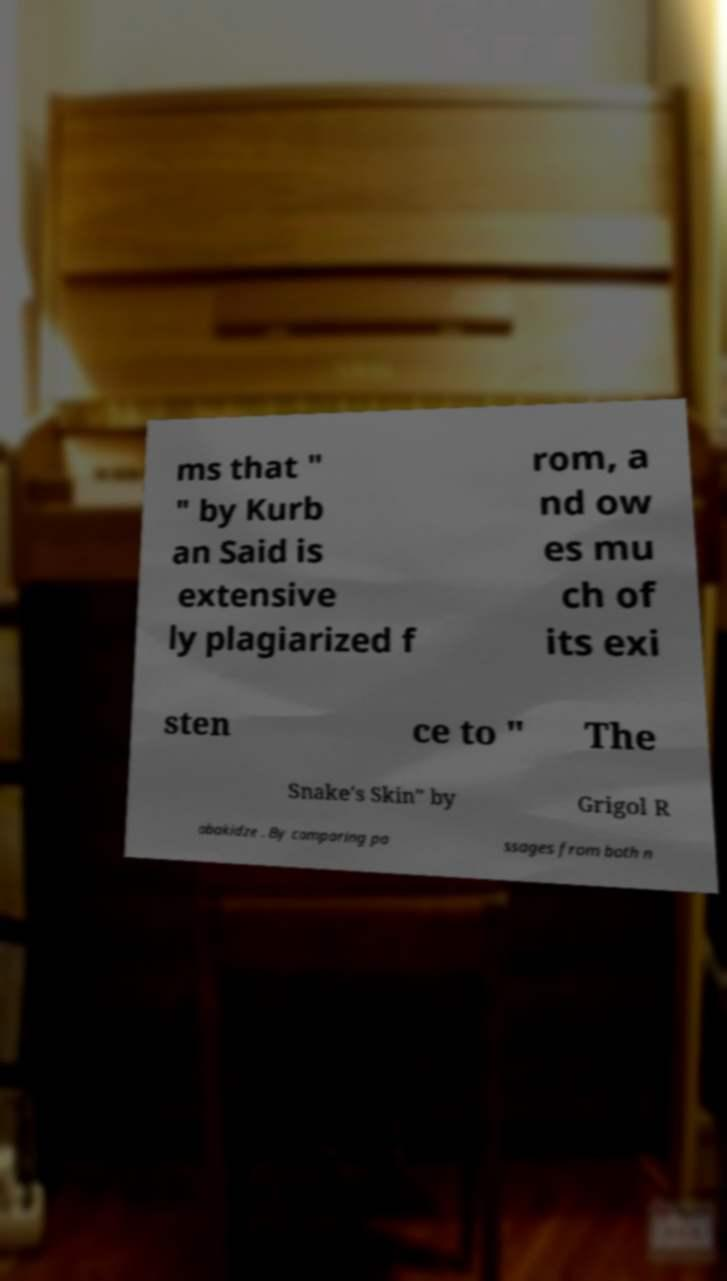Can you read and provide the text displayed in the image?This photo seems to have some interesting text. Can you extract and type it out for me? ms that " " by Kurb an Said is extensive ly plagiarized f rom, a nd ow es mu ch of its exi sten ce to " The Snake's Skin" by Grigol R obakidze . By comparing pa ssages from both n 